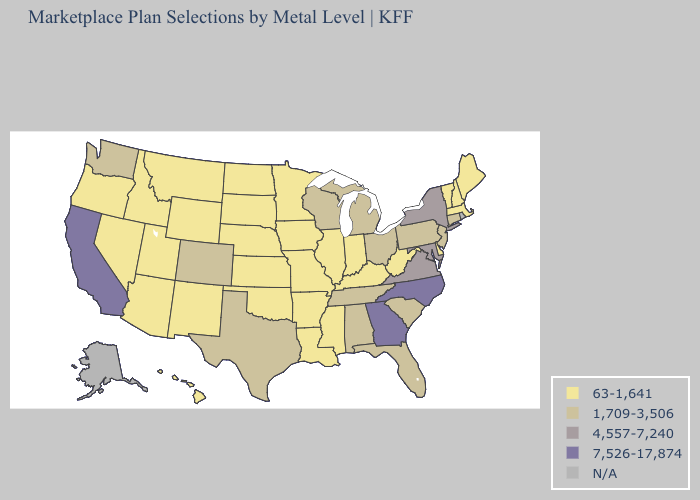What is the value of Florida?
Answer briefly. 1,709-3,506. Name the states that have a value in the range 4,557-7,240?
Quick response, please. Maryland, New York, Virginia. Does the map have missing data?
Answer briefly. Yes. Does Idaho have the highest value in the West?
Concise answer only. No. Name the states that have a value in the range 1,709-3,506?
Write a very short answer. Alabama, Colorado, Connecticut, Florida, Michigan, New Jersey, Ohio, Pennsylvania, South Carolina, Tennessee, Texas, Washington, Wisconsin. Which states hav the highest value in the MidWest?
Short answer required. Michigan, Ohio, Wisconsin. Name the states that have a value in the range 1,709-3,506?
Give a very brief answer. Alabama, Colorado, Connecticut, Florida, Michigan, New Jersey, Ohio, Pennsylvania, South Carolina, Tennessee, Texas, Washington, Wisconsin. Does North Carolina have the lowest value in the USA?
Quick response, please. No. Does the map have missing data?
Keep it brief. Yes. Name the states that have a value in the range 1,709-3,506?
Quick response, please. Alabama, Colorado, Connecticut, Florida, Michigan, New Jersey, Ohio, Pennsylvania, South Carolina, Tennessee, Texas, Washington, Wisconsin. Does California have the highest value in the West?
Short answer required. Yes. Does New York have the highest value in the Northeast?
Quick response, please. Yes. What is the highest value in the USA?
Be succinct. 7,526-17,874. 